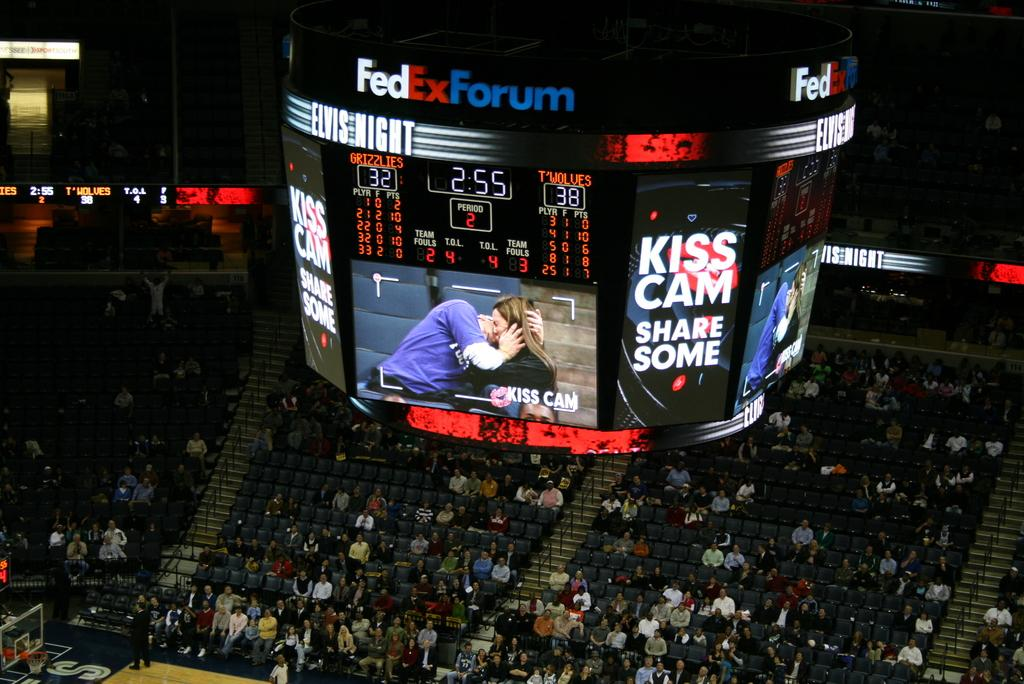What type of signage is visible in the image? There are hoardings in the image. What are the people in the image doing? Some people are sitting on chairs, while others are standing in the image. What sports equipment is present in the image? There is a basketball hoop in the image. What type of venue is depicted in the image? There is a stadium in the image. How can the scores of the game be seen in the image? There is a scoreboard in the image. Can you tell me how many frogs are used to clean the basketball court in the image? There are no frogs present in the image, and they are not used to clean the basketball court. What type of soap is used to wash the scoreboard in the image? There is no soap present in the image, and the scoreboard is not being washed. 